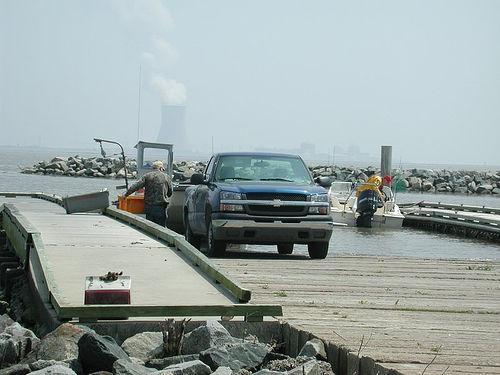What is the red and white box on the left used for? keeping cool 